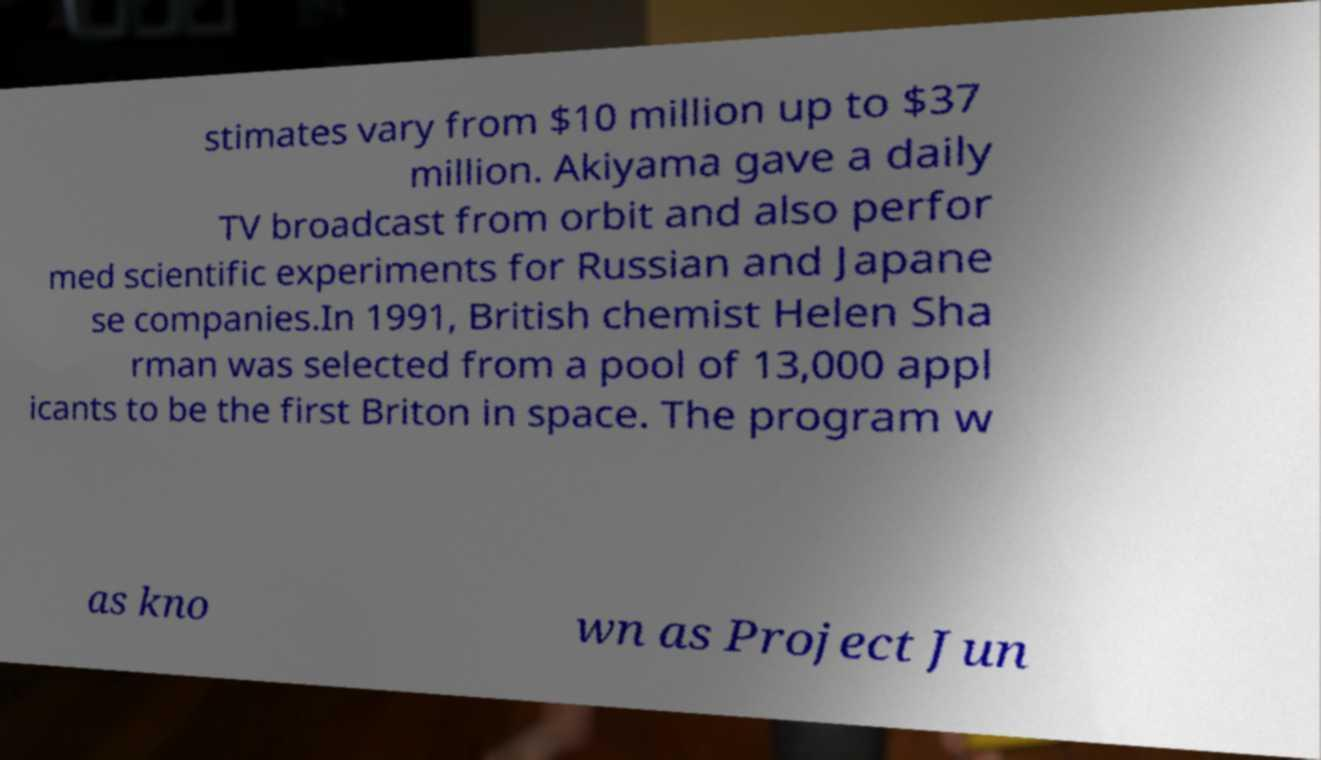Please read and relay the text visible in this image. What does it say? stimates vary from $10 million up to $37 million. Akiyama gave a daily TV broadcast from orbit and also perfor med scientific experiments for Russian and Japane se companies.In 1991, British chemist Helen Sha rman was selected from a pool of 13,000 appl icants to be the first Briton in space. The program w as kno wn as Project Jun 